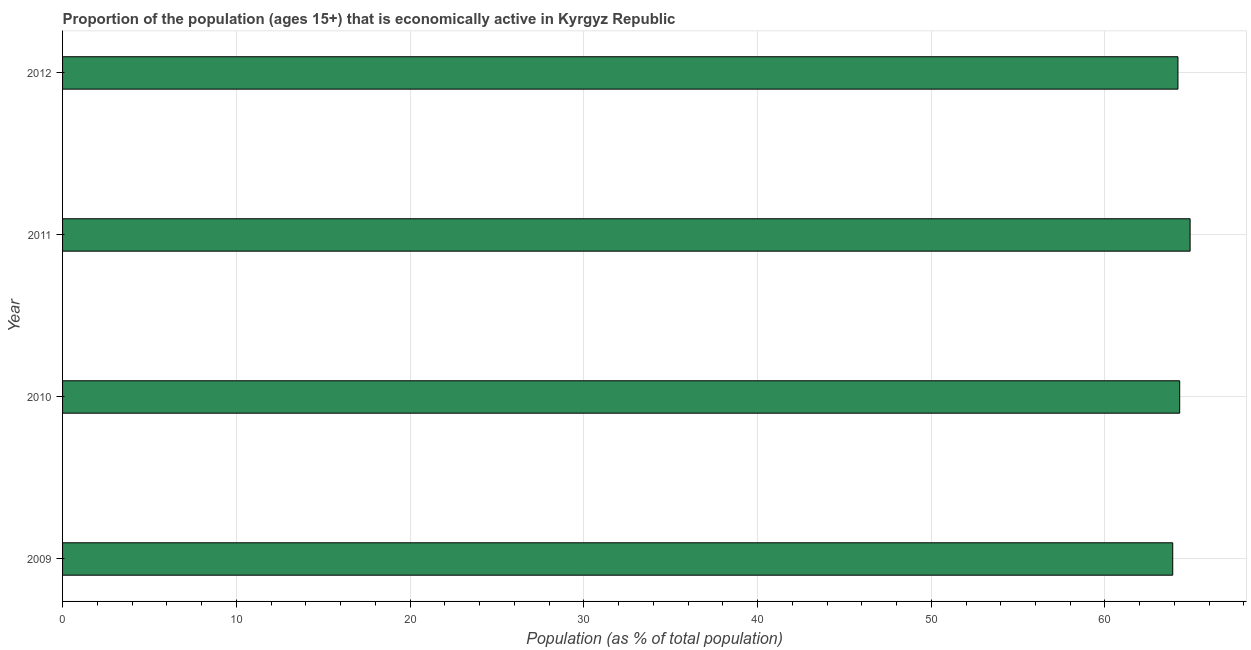Does the graph contain grids?
Your answer should be very brief. Yes. What is the title of the graph?
Make the answer very short. Proportion of the population (ages 15+) that is economically active in Kyrgyz Republic. What is the label or title of the X-axis?
Make the answer very short. Population (as % of total population). What is the percentage of economically active population in 2010?
Your response must be concise. 64.3. Across all years, what is the maximum percentage of economically active population?
Your answer should be compact. 64.9. Across all years, what is the minimum percentage of economically active population?
Provide a succinct answer. 63.9. In which year was the percentage of economically active population maximum?
Offer a very short reply. 2011. In which year was the percentage of economically active population minimum?
Ensure brevity in your answer.  2009. What is the sum of the percentage of economically active population?
Offer a very short reply. 257.3. What is the average percentage of economically active population per year?
Your answer should be very brief. 64.33. What is the median percentage of economically active population?
Make the answer very short. 64.25. Is the percentage of economically active population in 2009 less than that in 2010?
Make the answer very short. Yes. Is the difference between the percentage of economically active population in 2011 and 2012 greater than the difference between any two years?
Your response must be concise. No. What is the difference between the highest and the second highest percentage of economically active population?
Your answer should be compact. 0.6. Is the sum of the percentage of economically active population in 2009 and 2010 greater than the maximum percentage of economically active population across all years?
Make the answer very short. Yes. In how many years, is the percentage of economically active population greater than the average percentage of economically active population taken over all years?
Ensure brevity in your answer.  1. How many bars are there?
Offer a terse response. 4. How many years are there in the graph?
Your answer should be compact. 4. What is the difference between two consecutive major ticks on the X-axis?
Give a very brief answer. 10. What is the Population (as % of total population) in 2009?
Give a very brief answer. 63.9. What is the Population (as % of total population) of 2010?
Offer a terse response. 64.3. What is the Population (as % of total population) in 2011?
Provide a succinct answer. 64.9. What is the Population (as % of total population) in 2012?
Provide a short and direct response. 64.2. What is the difference between the Population (as % of total population) in 2009 and 2011?
Your answer should be very brief. -1. What is the difference between the Population (as % of total population) in 2010 and 2011?
Keep it short and to the point. -0.6. What is the difference between the Population (as % of total population) in 2010 and 2012?
Your answer should be very brief. 0.1. What is the difference between the Population (as % of total population) in 2011 and 2012?
Your response must be concise. 0.7. What is the ratio of the Population (as % of total population) in 2009 to that in 2010?
Give a very brief answer. 0.99. What is the ratio of the Population (as % of total population) in 2010 to that in 2011?
Offer a terse response. 0.99. 